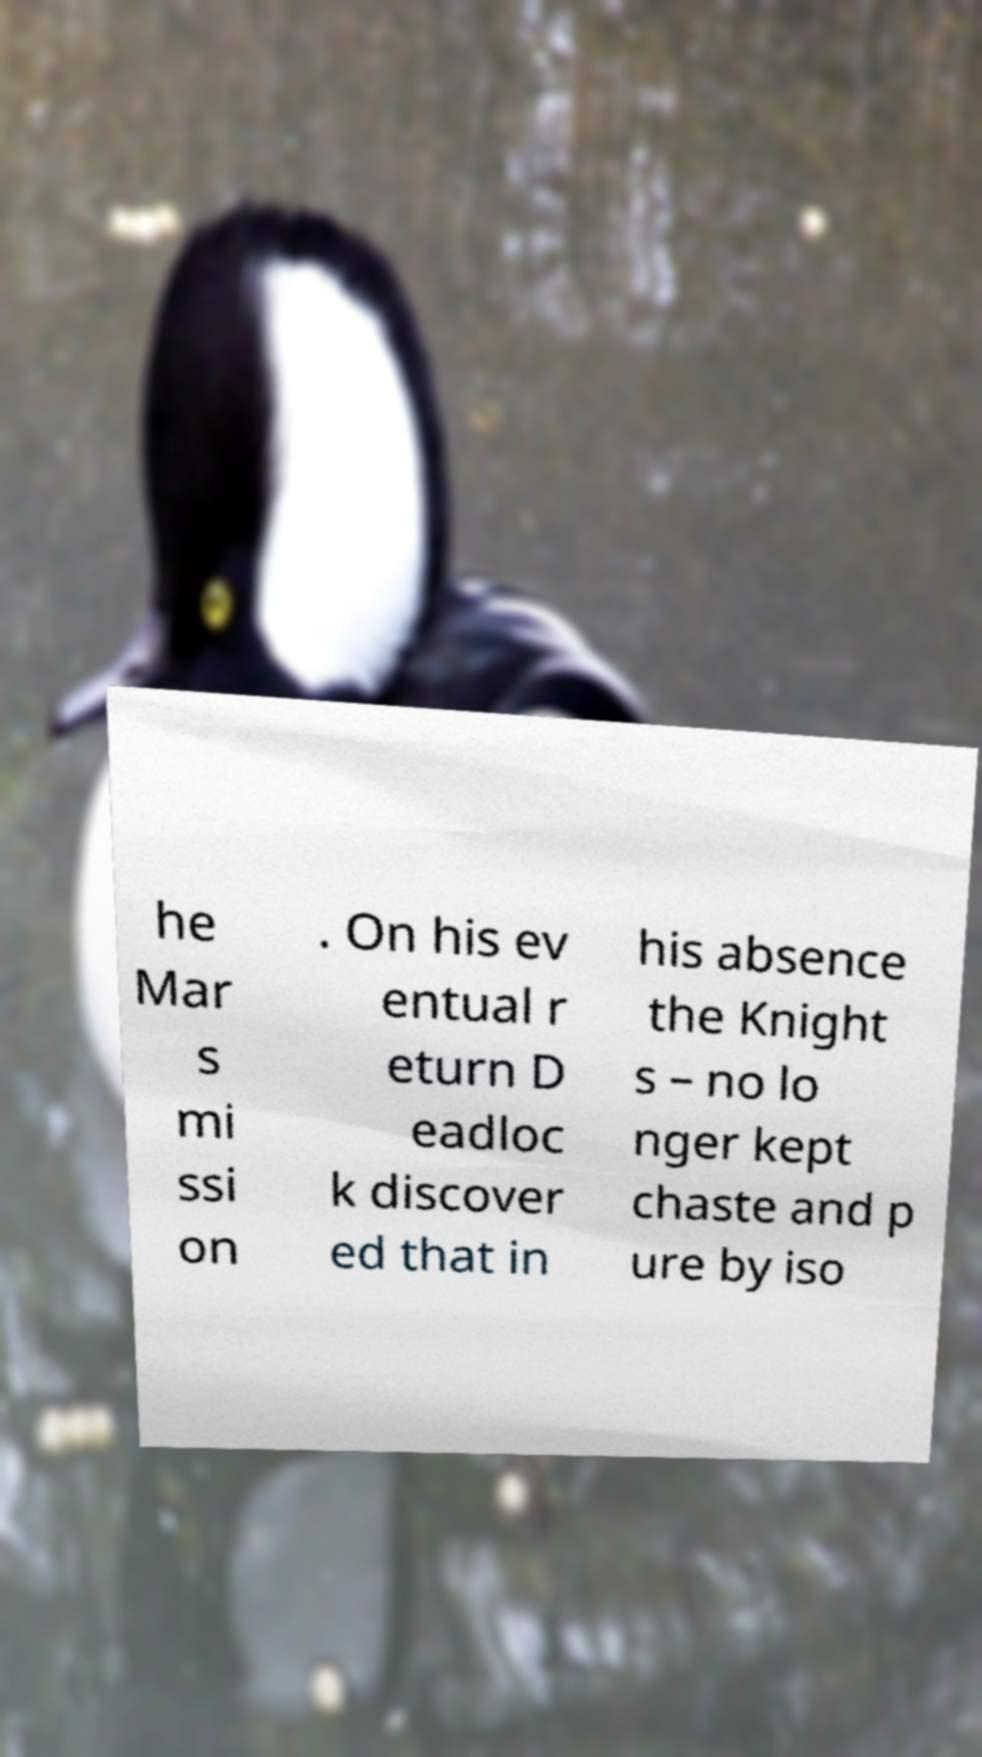Can you read and provide the text displayed in the image?This photo seems to have some interesting text. Can you extract and type it out for me? he Mar s mi ssi on . On his ev entual r eturn D eadloc k discover ed that in his absence the Knight s – no lo nger kept chaste and p ure by iso 